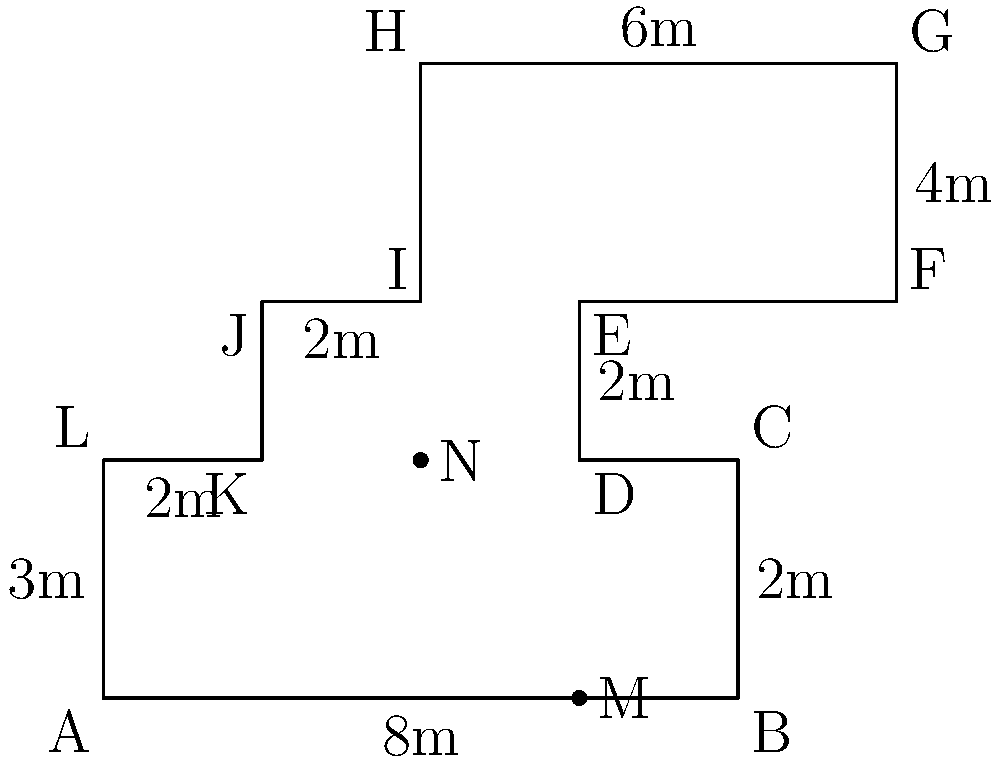As an adolescent psychiatrist overseeing the design of a new secure facility for young offenders, you're asked to calculate the perimeter of the proposed floor plan shown above. All measurements are in meters. What is the total perimeter of the secure facility? To find the perimeter, we need to add up all the lengths of the outer walls:

1. AB = 8m
2. BC = 3m
3. CD = 2m
4. DE = 2m
5. EF = 4m
6. FG = 3m
7. GH = 6m
8. HI = 3m
9. IJ = 2m
10. JK = 2m
11. KL = 2m
12. LA = 3m

Now, let's add all these lengths:

$$ \text{Perimeter} = 8 + 3 + 2 + 2 + 4 + 3 + 6 + 3 + 2 + 2 + 2 + 3 = 40 \text{ meters} $$

Therefore, the total perimeter of the secure facility is 40 meters.
Answer: 40 meters 